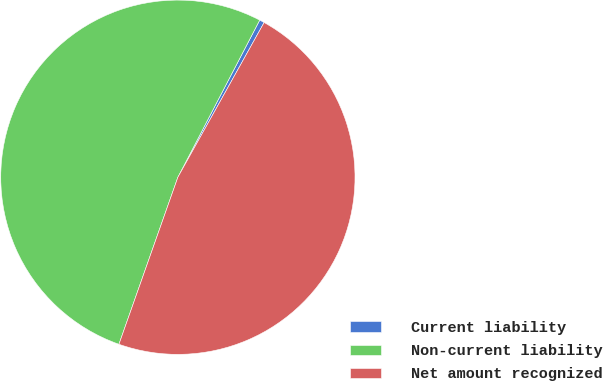<chart> <loc_0><loc_0><loc_500><loc_500><pie_chart><fcel>Current liability<fcel>Non-current liability<fcel>Net amount recognized<nl><fcel>0.45%<fcel>52.24%<fcel>47.3%<nl></chart> 